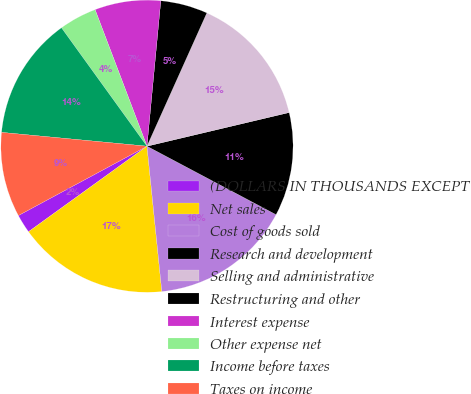Convert chart to OTSL. <chart><loc_0><loc_0><loc_500><loc_500><pie_chart><fcel>(DOLLARS IN THOUSANDS EXCEPT<fcel>Net sales<fcel>Cost of goods sold<fcel>Research and development<fcel>Selling and administrative<fcel>Restructuring and other<fcel>Interest expense<fcel>Other expense net<fcel>Income before taxes<fcel>Taxes on income<nl><fcel>2.08%<fcel>16.67%<fcel>15.62%<fcel>11.46%<fcel>14.58%<fcel>5.21%<fcel>7.29%<fcel>4.17%<fcel>13.54%<fcel>9.38%<nl></chart> 